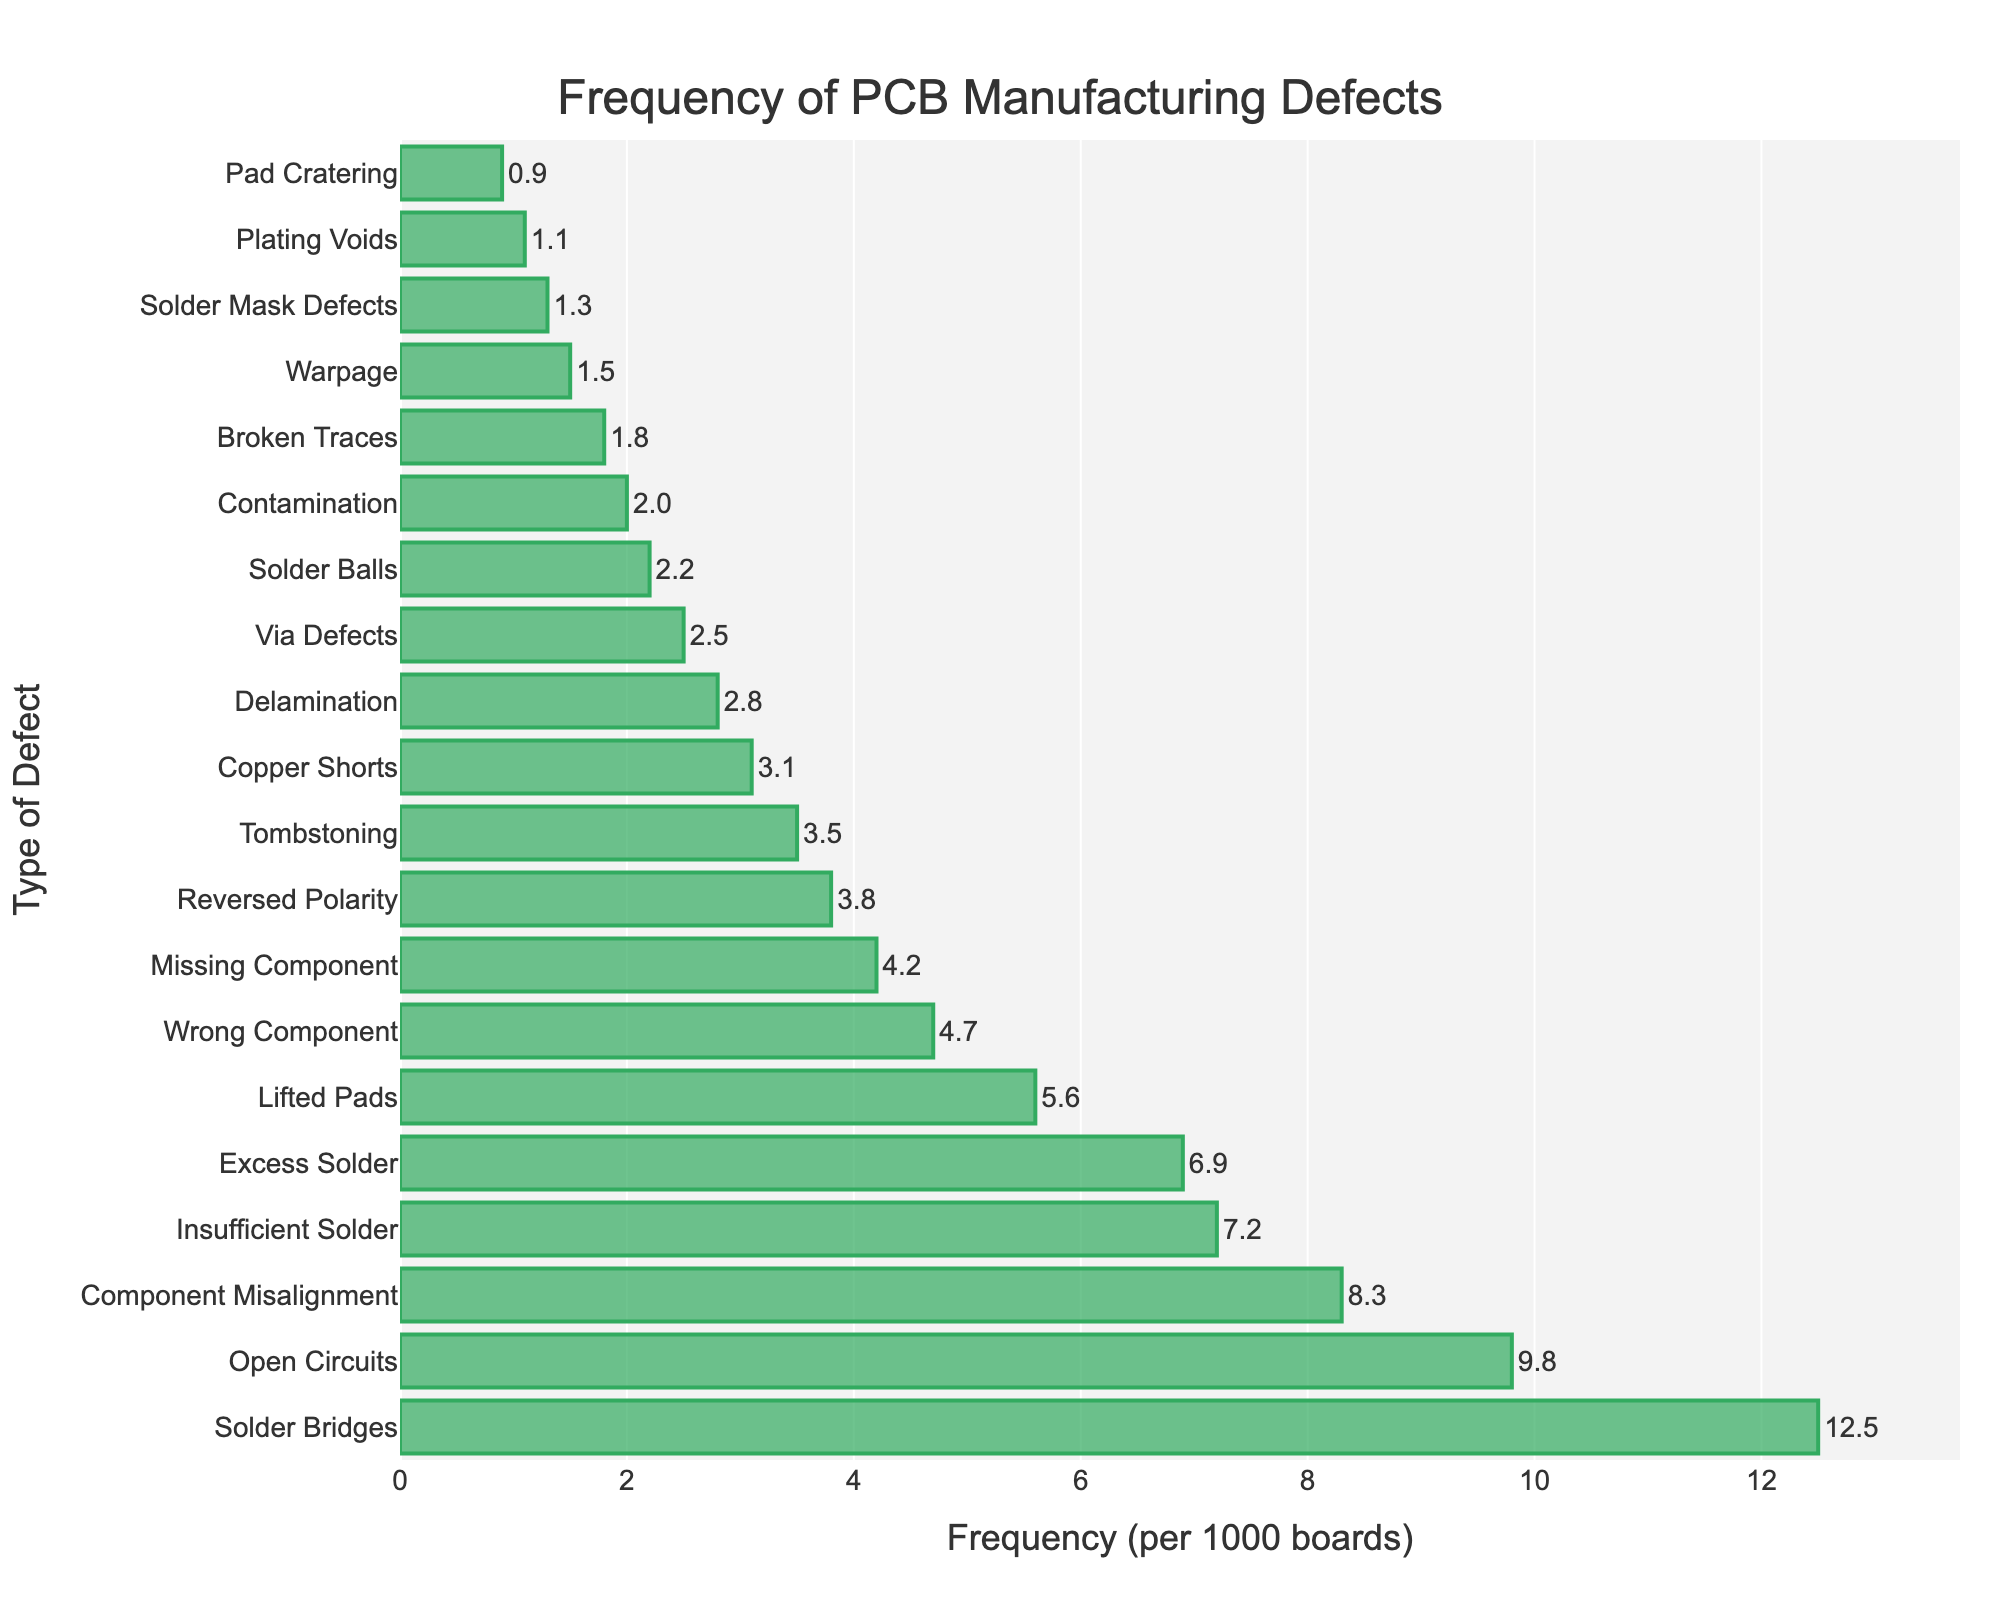Which defect type has the highest frequency in PCB manufacturing? Look at the longest bar in the chart, which represents the defect with the highest frequency.
Answer: Solder Bridges What is the total frequency of Open Circuits and Lifted Pads per 1000 boards? Add the frequencies of Open Circuits (9.8) and Lifted Pads (5.6) together. 9.8 + 5.6 = 15.4
Answer: 15.4 Which defect type has a lower frequency: Solder Balls or Via Defects? Compare the lengths of the bars representing Solder Balls and Via Defects.
Answer: Solder Balls How many defect types have a frequency greater than 5 per 1000 boards? Count the number of bars that exceed the frequency value of 5 on the x-axis.
Answer: 6 What is the frequency difference between Component Misalignment and Missing Component? Subtract the frequency of Missing Component (4.2) from Component Misalignment (8.3). 8.3 - 4.2 = 4.1
Answer: 4.1 Is the frequency of Contamination higher than Solder Mask Defects? Compare the lengths of the bars representing Contamination and Solder Mask Defects.
Answer: Yes What is the average frequency of the top three defect types? Sum the frequencies of the top three defects (12.5 for Solder Bridges, 9.8 for Open Circuits, and 8.3 for Component Misalignment) and divide by 3. (12.5 + 9.8 + 8.3) / 3 ≈ 10.2
Answer: 10.2 Which defect has a frequency closest to 3 per 1000 boards? Identify the bar that has a frequency nearest to 3 on the x-axis.
Answer: Copper Shorts If each type of defect were reduced by 2 per 1000 boards, which defect would then have a frequency of 5.5 per 1000 boards? Subtract 2 from each defect's frequency and see which one results in 5.5. Component Misalignment: 8.3 - 2 = 6.3, Insufficient Solder: 7.2 - 2 = 5.2, Excess Solder: 6.9 - 2 = 4.9, but Lifted Pads: 5.6 - 2 = 3.6. So, this scenario is not possible based on the given data.
Answer: N/A 